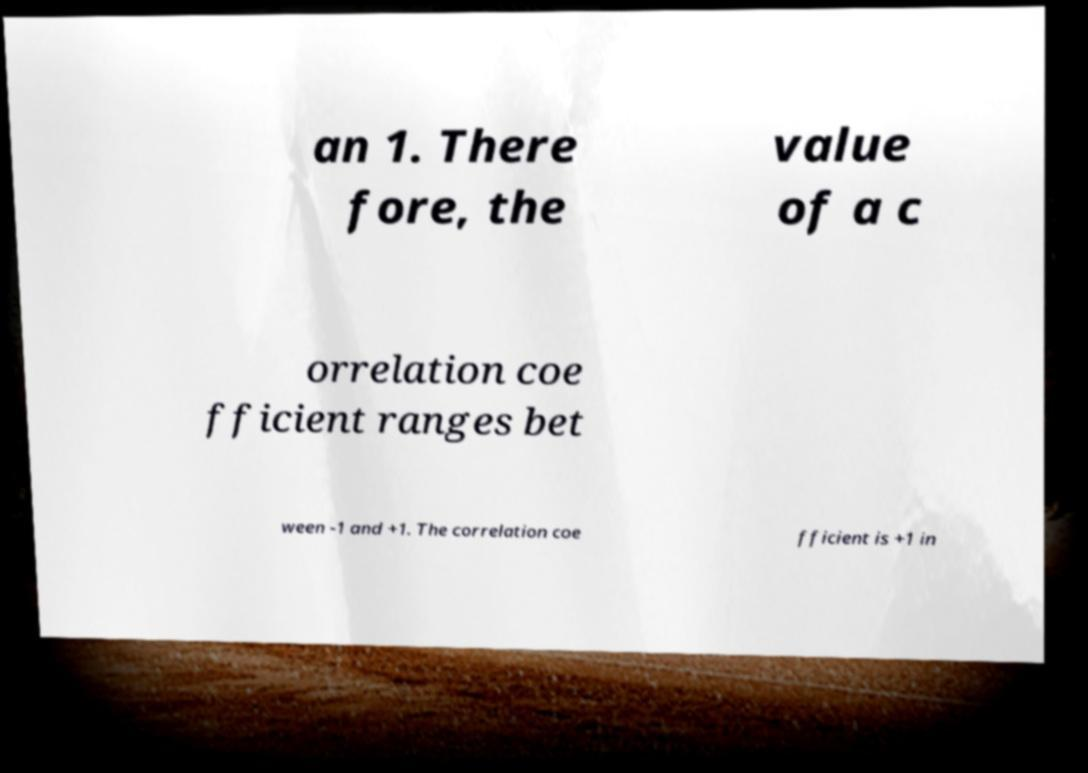Could you assist in decoding the text presented in this image and type it out clearly? an 1. There fore, the value of a c orrelation coe fficient ranges bet ween -1 and +1. The correlation coe fficient is +1 in 